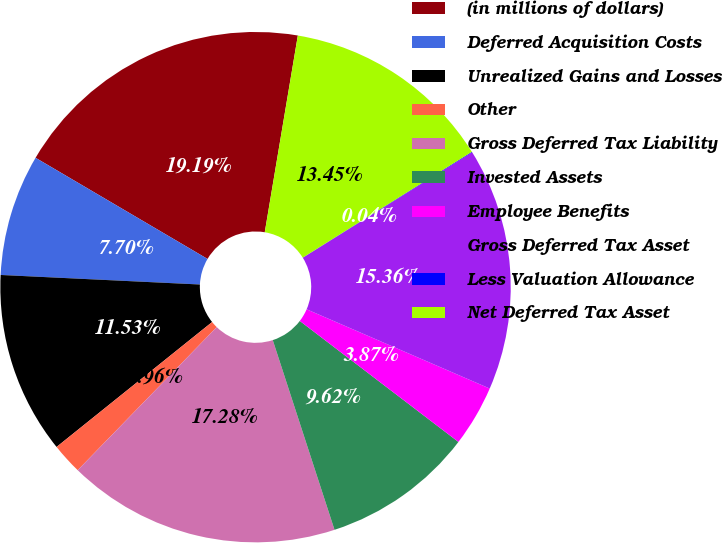Convert chart to OTSL. <chart><loc_0><loc_0><loc_500><loc_500><pie_chart><fcel>(in millions of dollars)<fcel>Deferred Acquisition Costs<fcel>Unrealized Gains and Losses<fcel>Other<fcel>Gross Deferred Tax Liability<fcel>Invested Assets<fcel>Employee Benefits<fcel>Gross Deferred Tax Asset<fcel>Less Valuation Allowance<fcel>Net Deferred Tax Asset<nl><fcel>19.19%<fcel>7.7%<fcel>11.53%<fcel>1.96%<fcel>17.28%<fcel>9.62%<fcel>3.87%<fcel>15.36%<fcel>0.04%<fcel>13.45%<nl></chart> 